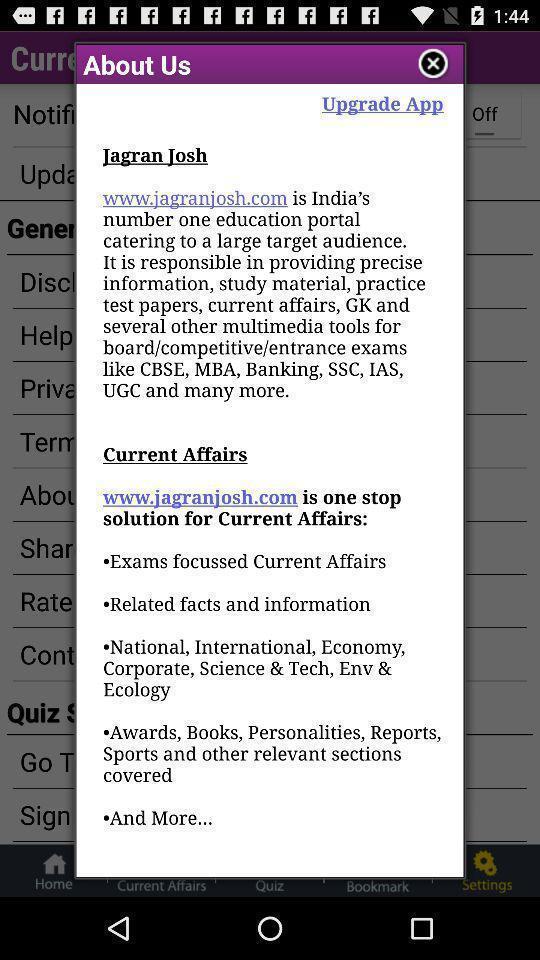Summarize the information in this screenshot. Pop-up showing 'about info of a learning app. 